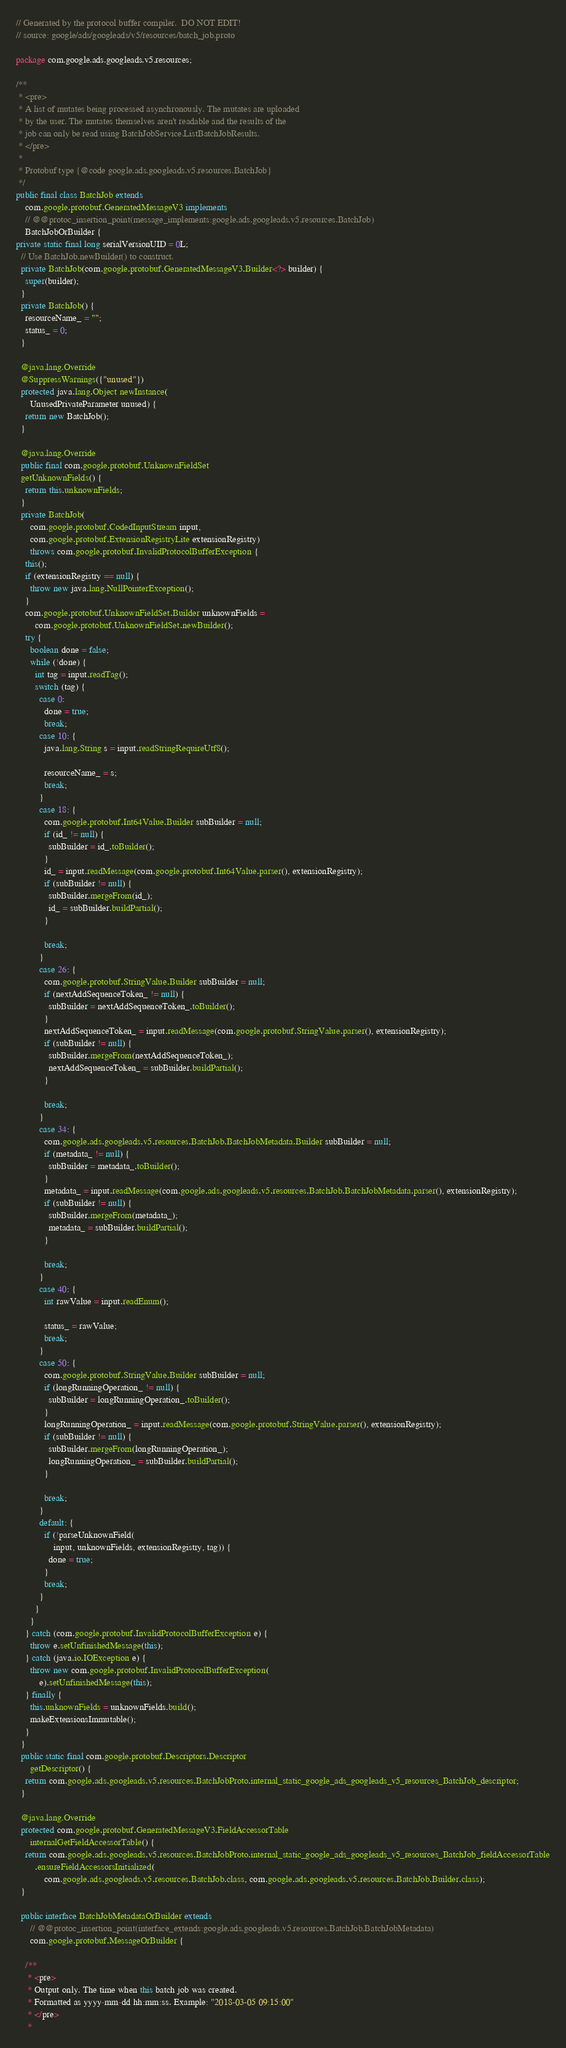Convert code to text. <code><loc_0><loc_0><loc_500><loc_500><_Java_>// Generated by the protocol buffer compiler.  DO NOT EDIT!
// source: google/ads/googleads/v5/resources/batch_job.proto

package com.google.ads.googleads.v5.resources;

/**
 * <pre>
 * A list of mutates being processed asynchronously. The mutates are uploaded
 * by the user. The mutates themselves aren't readable and the results of the
 * job can only be read using BatchJobService.ListBatchJobResults.
 * </pre>
 *
 * Protobuf type {@code google.ads.googleads.v5.resources.BatchJob}
 */
public final class BatchJob extends
    com.google.protobuf.GeneratedMessageV3 implements
    // @@protoc_insertion_point(message_implements:google.ads.googleads.v5.resources.BatchJob)
    BatchJobOrBuilder {
private static final long serialVersionUID = 0L;
  // Use BatchJob.newBuilder() to construct.
  private BatchJob(com.google.protobuf.GeneratedMessageV3.Builder<?> builder) {
    super(builder);
  }
  private BatchJob() {
    resourceName_ = "";
    status_ = 0;
  }

  @java.lang.Override
  @SuppressWarnings({"unused"})
  protected java.lang.Object newInstance(
      UnusedPrivateParameter unused) {
    return new BatchJob();
  }

  @java.lang.Override
  public final com.google.protobuf.UnknownFieldSet
  getUnknownFields() {
    return this.unknownFields;
  }
  private BatchJob(
      com.google.protobuf.CodedInputStream input,
      com.google.protobuf.ExtensionRegistryLite extensionRegistry)
      throws com.google.protobuf.InvalidProtocolBufferException {
    this();
    if (extensionRegistry == null) {
      throw new java.lang.NullPointerException();
    }
    com.google.protobuf.UnknownFieldSet.Builder unknownFields =
        com.google.protobuf.UnknownFieldSet.newBuilder();
    try {
      boolean done = false;
      while (!done) {
        int tag = input.readTag();
        switch (tag) {
          case 0:
            done = true;
            break;
          case 10: {
            java.lang.String s = input.readStringRequireUtf8();

            resourceName_ = s;
            break;
          }
          case 18: {
            com.google.protobuf.Int64Value.Builder subBuilder = null;
            if (id_ != null) {
              subBuilder = id_.toBuilder();
            }
            id_ = input.readMessage(com.google.protobuf.Int64Value.parser(), extensionRegistry);
            if (subBuilder != null) {
              subBuilder.mergeFrom(id_);
              id_ = subBuilder.buildPartial();
            }

            break;
          }
          case 26: {
            com.google.protobuf.StringValue.Builder subBuilder = null;
            if (nextAddSequenceToken_ != null) {
              subBuilder = nextAddSequenceToken_.toBuilder();
            }
            nextAddSequenceToken_ = input.readMessage(com.google.protobuf.StringValue.parser(), extensionRegistry);
            if (subBuilder != null) {
              subBuilder.mergeFrom(nextAddSequenceToken_);
              nextAddSequenceToken_ = subBuilder.buildPartial();
            }

            break;
          }
          case 34: {
            com.google.ads.googleads.v5.resources.BatchJob.BatchJobMetadata.Builder subBuilder = null;
            if (metadata_ != null) {
              subBuilder = metadata_.toBuilder();
            }
            metadata_ = input.readMessage(com.google.ads.googleads.v5.resources.BatchJob.BatchJobMetadata.parser(), extensionRegistry);
            if (subBuilder != null) {
              subBuilder.mergeFrom(metadata_);
              metadata_ = subBuilder.buildPartial();
            }

            break;
          }
          case 40: {
            int rawValue = input.readEnum();

            status_ = rawValue;
            break;
          }
          case 50: {
            com.google.protobuf.StringValue.Builder subBuilder = null;
            if (longRunningOperation_ != null) {
              subBuilder = longRunningOperation_.toBuilder();
            }
            longRunningOperation_ = input.readMessage(com.google.protobuf.StringValue.parser(), extensionRegistry);
            if (subBuilder != null) {
              subBuilder.mergeFrom(longRunningOperation_);
              longRunningOperation_ = subBuilder.buildPartial();
            }

            break;
          }
          default: {
            if (!parseUnknownField(
                input, unknownFields, extensionRegistry, tag)) {
              done = true;
            }
            break;
          }
        }
      }
    } catch (com.google.protobuf.InvalidProtocolBufferException e) {
      throw e.setUnfinishedMessage(this);
    } catch (java.io.IOException e) {
      throw new com.google.protobuf.InvalidProtocolBufferException(
          e).setUnfinishedMessage(this);
    } finally {
      this.unknownFields = unknownFields.build();
      makeExtensionsImmutable();
    }
  }
  public static final com.google.protobuf.Descriptors.Descriptor
      getDescriptor() {
    return com.google.ads.googleads.v5.resources.BatchJobProto.internal_static_google_ads_googleads_v5_resources_BatchJob_descriptor;
  }

  @java.lang.Override
  protected com.google.protobuf.GeneratedMessageV3.FieldAccessorTable
      internalGetFieldAccessorTable() {
    return com.google.ads.googleads.v5.resources.BatchJobProto.internal_static_google_ads_googleads_v5_resources_BatchJob_fieldAccessorTable
        .ensureFieldAccessorsInitialized(
            com.google.ads.googleads.v5.resources.BatchJob.class, com.google.ads.googleads.v5.resources.BatchJob.Builder.class);
  }

  public interface BatchJobMetadataOrBuilder extends
      // @@protoc_insertion_point(interface_extends:google.ads.googleads.v5.resources.BatchJob.BatchJobMetadata)
      com.google.protobuf.MessageOrBuilder {

    /**
     * <pre>
     * Output only. The time when this batch job was created.
     * Formatted as yyyy-mm-dd hh:mm:ss. Example: "2018-03-05 09:15:00"
     * </pre>
     *</code> 